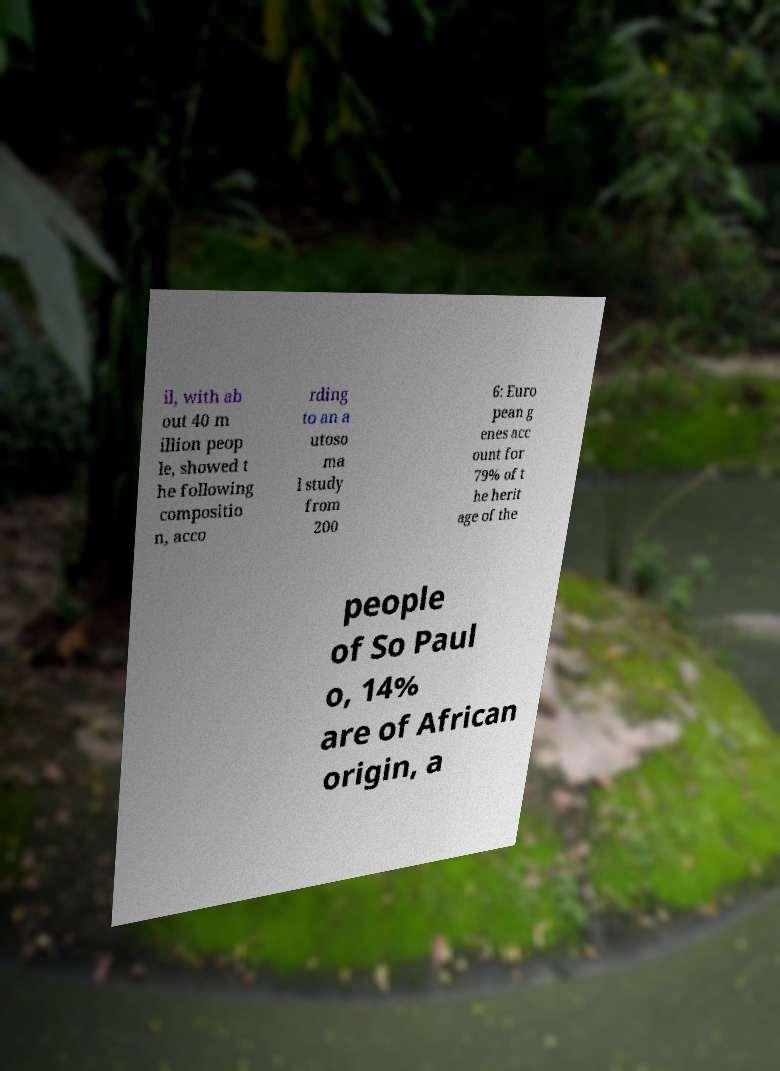For documentation purposes, I need the text within this image transcribed. Could you provide that? il, with ab out 40 m illion peop le, showed t he following compositio n, acco rding to an a utoso ma l study from 200 6: Euro pean g enes acc ount for 79% of t he herit age of the people of So Paul o, 14% are of African origin, a 